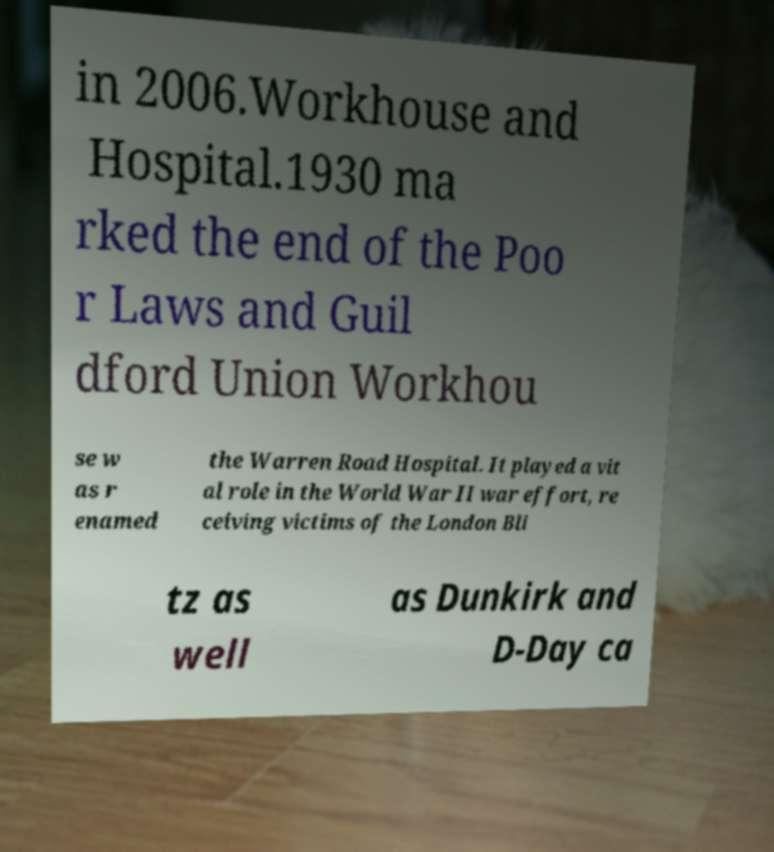Could you extract and type out the text from this image? in 2006.Workhouse and Hospital.1930 ma rked the end of the Poo r Laws and Guil dford Union Workhou se w as r enamed the Warren Road Hospital. It played a vit al role in the World War II war effort, re ceiving victims of the London Bli tz as well as Dunkirk and D-Day ca 